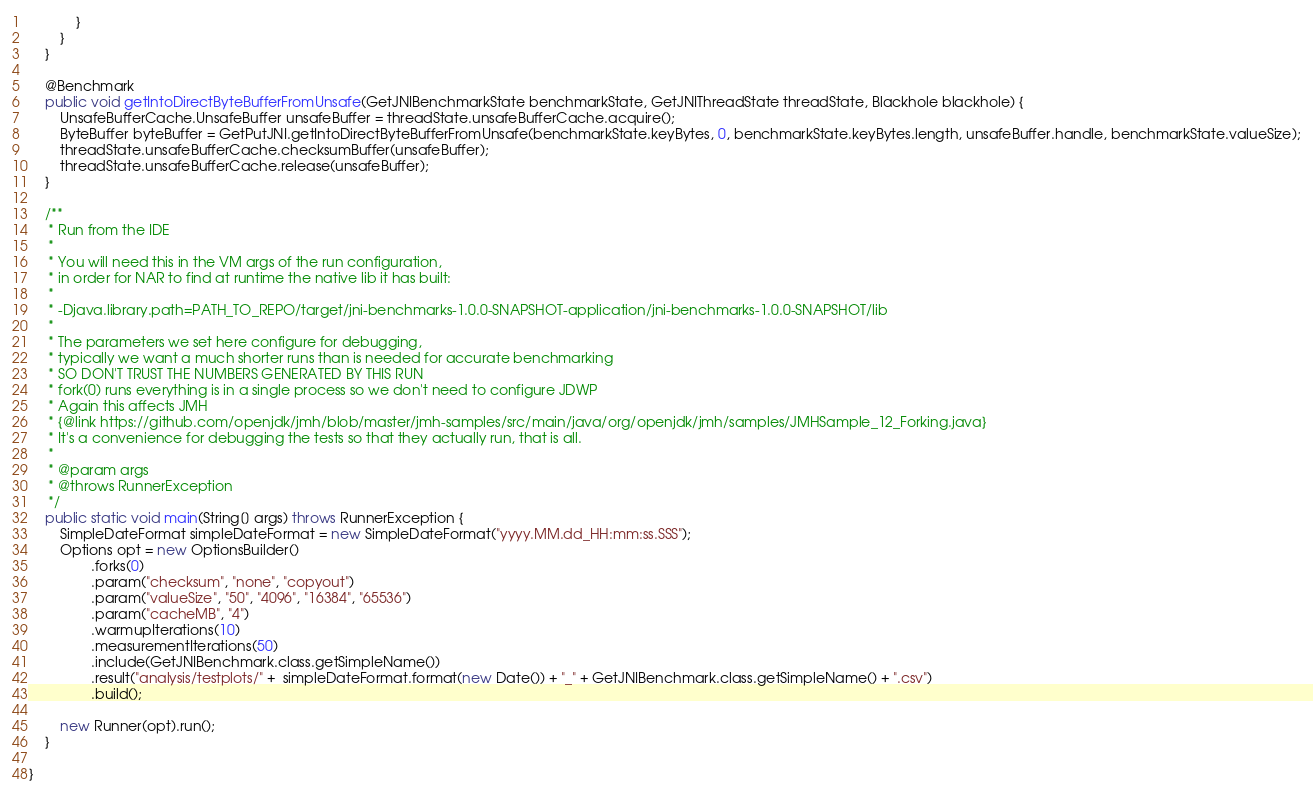Convert code to text. <code><loc_0><loc_0><loc_500><loc_500><_Java_>            }
        }
    }

    @Benchmark
    public void getIntoDirectByteBufferFromUnsafe(GetJNIBenchmarkState benchmarkState, GetJNIThreadState threadState, Blackhole blackhole) {
        UnsafeBufferCache.UnsafeBuffer unsafeBuffer = threadState.unsafeBufferCache.acquire();
        ByteBuffer byteBuffer = GetPutJNI.getIntoDirectByteBufferFromUnsafe(benchmarkState.keyBytes, 0, benchmarkState.keyBytes.length, unsafeBuffer.handle, benchmarkState.valueSize);
        threadState.unsafeBufferCache.checksumBuffer(unsafeBuffer);
        threadState.unsafeBufferCache.release(unsafeBuffer);
    }

    /**
     * Run from the IDE
     *
     * You will need this in the VM args of the run configuration,
     * in order for NAR to find at runtime the native lib it has built:
     *
     * -Djava.library.path=PATH_TO_REPO/target/jni-benchmarks-1.0.0-SNAPSHOT-application/jni-benchmarks-1.0.0-SNAPSHOT/lib
     *
     * The parameters we set here configure for debugging,
     * typically we want a much shorter runs than is needed for accurate benchmarking
     * SO DON'T TRUST THE NUMBERS GENERATED BY THIS RUN
     * fork(0) runs everything is in a single process so we don't need to configure JDWP
     * Again this affects JMH
     * {@link https://github.com/openjdk/jmh/blob/master/jmh-samples/src/main/java/org/openjdk/jmh/samples/JMHSample_12_Forking.java}
     * It's a convenience for debugging the tests so that they actually run, that is all.
     *
     * @param args
     * @throws RunnerException
     */
    public static void main(String[] args) throws RunnerException {
        SimpleDateFormat simpleDateFormat = new SimpleDateFormat("yyyy.MM.dd_HH:mm:ss.SSS");
        Options opt = new OptionsBuilder()
                .forks(0)
                .param("checksum", "none", "copyout")
                .param("valueSize", "50", "4096", "16384", "65536")
                .param("cacheMB", "4")
                .warmupIterations(10)
                .measurementIterations(50)
                .include(GetJNIBenchmark.class.getSimpleName())
                .result("analysis/testplots/" +  simpleDateFormat.format(new Date()) + "_" + GetJNIBenchmark.class.getSimpleName() + ".csv")
                .build();

        new Runner(opt).run();
    }

}
</code> 